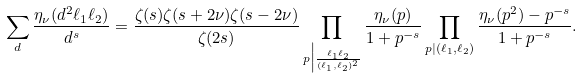<formula> <loc_0><loc_0><loc_500><loc_500>& \sum _ { d } \frac { \eta _ { \nu } ( d ^ { 2 } \ell _ { 1 } \ell _ { 2 } ) } { d ^ { s } } = \frac { \zeta ( s ) \zeta ( s + 2 \nu ) \zeta ( s - 2 \nu ) } { \zeta ( 2 s ) } \prod _ { p \Big | \frac { \ell _ { 1 } \ell _ { 2 } } { ( \ell _ { 1 } , \ell _ { 2 } ) ^ { 2 } } } \frac { \eta _ { \nu } ( p ) } { 1 + p ^ { - s } } \prod _ { p | ( \ell _ { 1 } , \ell _ { 2 } ) } \frac { \eta _ { \nu } ( p ^ { 2 } ) - p ^ { - s } } { 1 + p ^ { - s } } .</formula> 